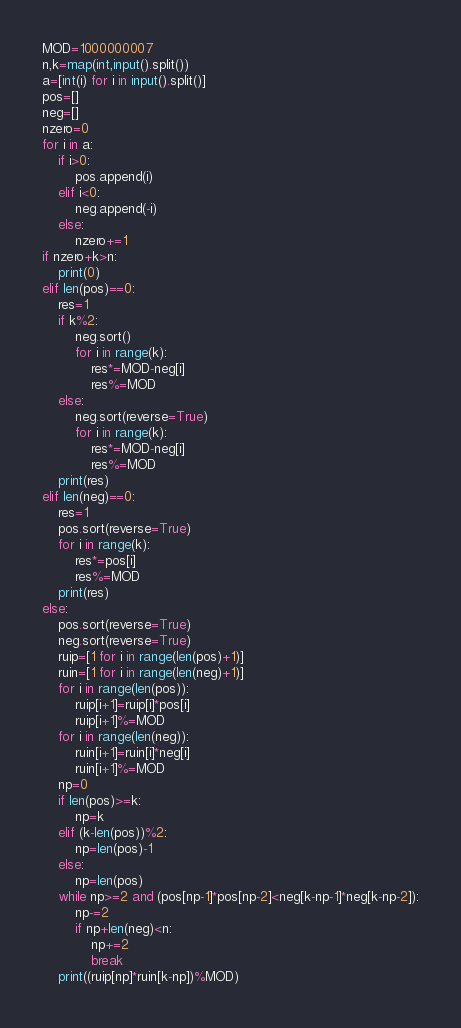Convert code to text. <code><loc_0><loc_0><loc_500><loc_500><_Python_>MOD=1000000007
n,k=map(int,input().split())
a=[int(i) for i in input().split()]
pos=[]
neg=[]
nzero=0
for i in a:
    if i>0:
        pos.append(i)
    elif i<0:
        neg.append(-i)
    else:
        nzero+=1
if nzero+k>n:
    print(0)
elif len(pos)==0:
    res=1
    if k%2:
        neg.sort()
        for i in range(k):
            res*=MOD-neg[i]
            res%=MOD
    else:
        neg.sort(reverse=True)
        for i in range(k):
            res*=MOD-neg[i]
            res%=MOD
    print(res)
elif len(neg)==0:
    res=1
    pos.sort(reverse=True)
    for i in range(k):
        res*=pos[i]
        res%=MOD
    print(res)
else:
    pos.sort(reverse=True)
    neg.sort(reverse=True)
    ruip=[1 for i in range(len(pos)+1)]
    ruin=[1 for i in range(len(neg)+1)]
    for i in range(len(pos)):
        ruip[i+1]=ruip[i]*pos[i]
        ruip[i+1]%=MOD
    for i in range(len(neg)):
        ruin[i+1]=ruin[i]*neg[i]
        ruin[i+1]%=MOD
    np=0
    if len(pos)>=k:
        np=k
    elif (k-len(pos))%2:
        np=len(pos)-1
    else:
        np=len(pos)
    while np>=2 and (pos[np-1]*pos[np-2]<neg[k-np-1]*neg[k-np-2]):
        np-=2
        if np+len(neg)<n:
            np+=2
            break
    print((ruip[np]*ruin[k-np])%MOD)
</code> 